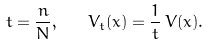<formula> <loc_0><loc_0><loc_500><loc_500>t = \frac { n } { N } , \quad V _ { t } ( x ) = \frac { 1 } { t } \, V ( x ) .</formula> 